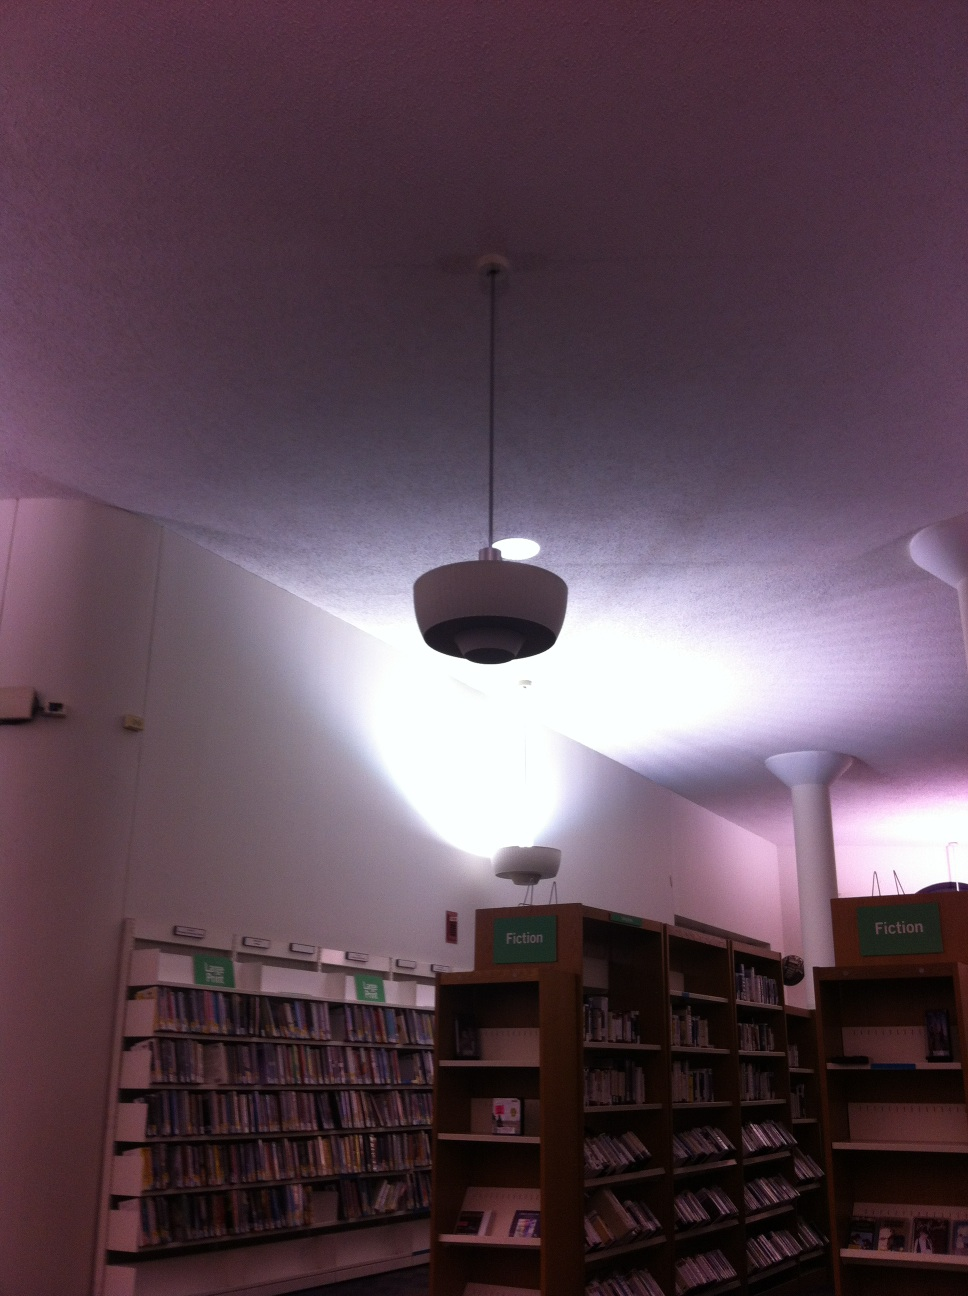Where am I? You are in a library, surrounded by bookshelves filled with various books. The signs on top of the shelves indicate that you are in the Fiction section. 